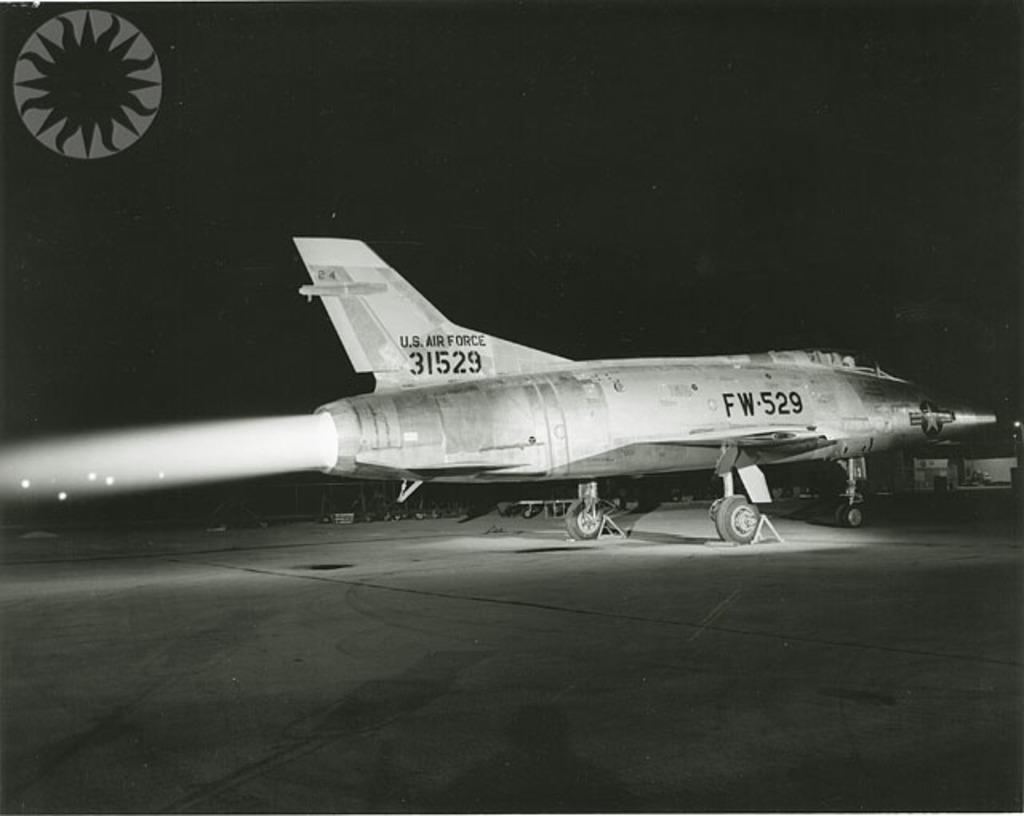Provide a one-sentence caption for the provided image. A U.S. Air Force fighter jet is parked on the runway. 